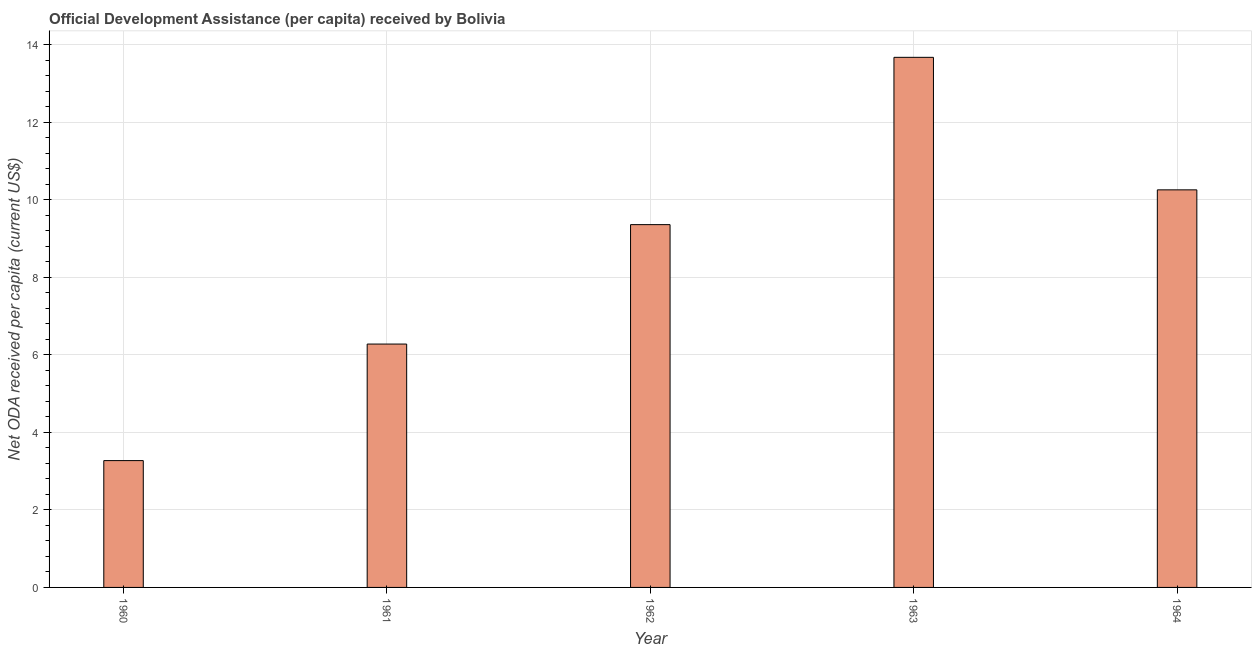What is the title of the graph?
Give a very brief answer. Official Development Assistance (per capita) received by Bolivia. What is the label or title of the X-axis?
Your answer should be very brief. Year. What is the label or title of the Y-axis?
Provide a succinct answer. Net ODA received per capita (current US$). What is the net oda received per capita in 1961?
Provide a short and direct response. 6.28. Across all years, what is the maximum net oda received per capita?
Your response must be concise. 13.67. Across all years, what is the minimum net oda received per capita?
Offer a very short reply. 3.27. In which year was the net oda received per capita maximum?
Offer a very short reply. 1963. In which year was the net oda received per capita minimum?
Your response must be concise. 1960. What is the sum of the net oda received per capita?
Your answer should be compact. 42.83. What is the difference between the net oda received per capita in 1961 and 1963?
Keep it short and to the point. -7.39. What is the average net oda received per capita per year?
Your answer should be compact. 8.57. What is the median net oda received per capita?
Give a very brief answer. 9.36. What is the ratio of the net oda received per capita in 1963 to that in 1964?
Give a very brief answer. 1.33. Is the net oda received per capita in 1960 less than that in 1963?
Make the answer very short. Yes. Is the difference between the net oda received per capita in 1960 and 1962 greater than the difference between any two years?
Ensure brevity in your answer.  No. What is the difference between the highest and the second highest net oda received per capita?
Provide a short and direct response. 3.42. Is the sum of the net oda received per capita in 1961 and 1964 greater than the maximum net oda received per capita across all years?
Offer a very short reply. Yes. What is the difference between the highest and the lowest net oda received per capita?
Ensure brevity in your answer.  10.4. In how many years, is the net oda received per capita greater than the average net oda received per capita taken over all years?
Give a very brief answer. 3. How many bars are there?
Make the answer very short. 5. Are all the bars in the graph horizontal?
Your answer should be very brief. No. Are the values on the major ticks of Y-axis written in scientific E-notation?
Offer a very short reply. No. What is the Net ODA received per capita (current US$) in 1960?
Your answer should be very brief. 3.27. What is the Net ODA received per capita (current US$) in 1961?
Offer a terse response. 6.28. What is the Net ODA received per capita (current US$) of 1962?
Offer a terse response. 9.36. What is the Net ODA received per capita (current US$) of 1963?
Make the answer very short. 13.67. What is the Net ODA received per capita (current US$) of 1964?
Make the answer very short. 10.25. What is the difference between the Net ODA received per capita (current US$) in 1960 and 1961?
Your answer should be compact. -3.01. What is the difference between the Net ODA received per capita (current US$) in 1960 and 1962?
Provide a short and direct response. -6.09. What is the difference between the Net ODA received per capita (current US$) in 1960 and 1963?
Your answer should be very brief. -10.4. What is the difference between the Net ODA received per capita (current US$) in 1960 and 1964?
Your answer should be very brief. -6.98. What is the difference between the Net ODA received per capita (current US$) in 1961 and 1962?
Your answer should be compact. -3.08. What is the difference between the Net ODA received per capita (current US$) in 1961 and 1963?
Provide a short and direct response. -7.39. What is the difference between the Net ODA received per capita (current US$) in 1961 and 1964?
Offer a terse response. -3.98. What is the difference between the Net ODA received per capita (current US$) in 1962 and 1963?
Ensure brevity in your answer.  -4.31. What is the difference between the Net ODA received per capita (current US$) in 1962 and 1964?
Offer a very short reply. -0.9. What is the difference between the Net ODA received per capita (current US$) in 1963 and 1964?
Your response must be concise. 3.42. What is the ratio of the Net ODA received per capita (current US$) in 1960 to that in 1961?
Keep it short and to the point. 0.52. What is the ratio of the Net ODA received per capita (current US$) in 1960 to that in 1963?
Your response must be concise. 0.24. What is the ratio of the Net ODA received per capita (current US$) in 1960 to that in 1964?
Your answer should be very brief. 0.32. What is the ratio of the Net ODA received per capita (current US$) in 1961 to that in 1962?
Keep it short and to the point. 0.67. What is the ratio of the Net ODA received per capita (current US$) in 1961 to that in 1963?
Give a very brief answer. 0.46. What is the ratio of the Net ODA received per capita (current US$) in 1961 to that in 1964?
Your answer should be very brief. 0.61. What is the ratio of the Net ODA received per capita (current US$) in 1962 to that in 1963?
Your answer should be very brief. 0.68. What is the ratio of the Net ODA received per capita (current US$) in 1962 to that in 1964?
Give a very brief answer. 0.91. What is the ratio of the Net ODA received per capita (current US$) in 1963 to that in 1964?
Give a very brief answer. 1.33. 